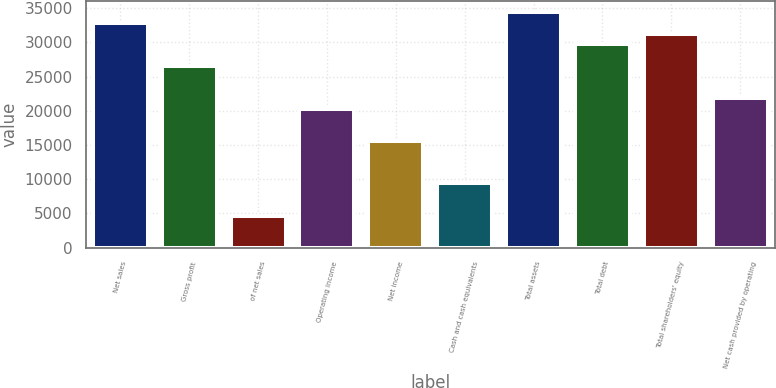<chart> <loc_0><loc_0><loc_500><loc_500><bar_chart><fcel>Net sales<fcel>Gross profit<fcel>of net sales<fcel>Operating income<fcel>Net income<fcel>Cash and cash equivalents<fcel>Total assets<fcel>Total debt<fcel>Total shareholders' equity<fcel>Net cash provided by operating<nl><fcel>32840.1<fcel>26585.4<fcel>4694.01<fcel>20330.7<fcel>15639.7<fcel>9385.02<fcel>34403.7<fcel>29712.7<fcel>31276.4<fcel>21894.4<nl></chart> 